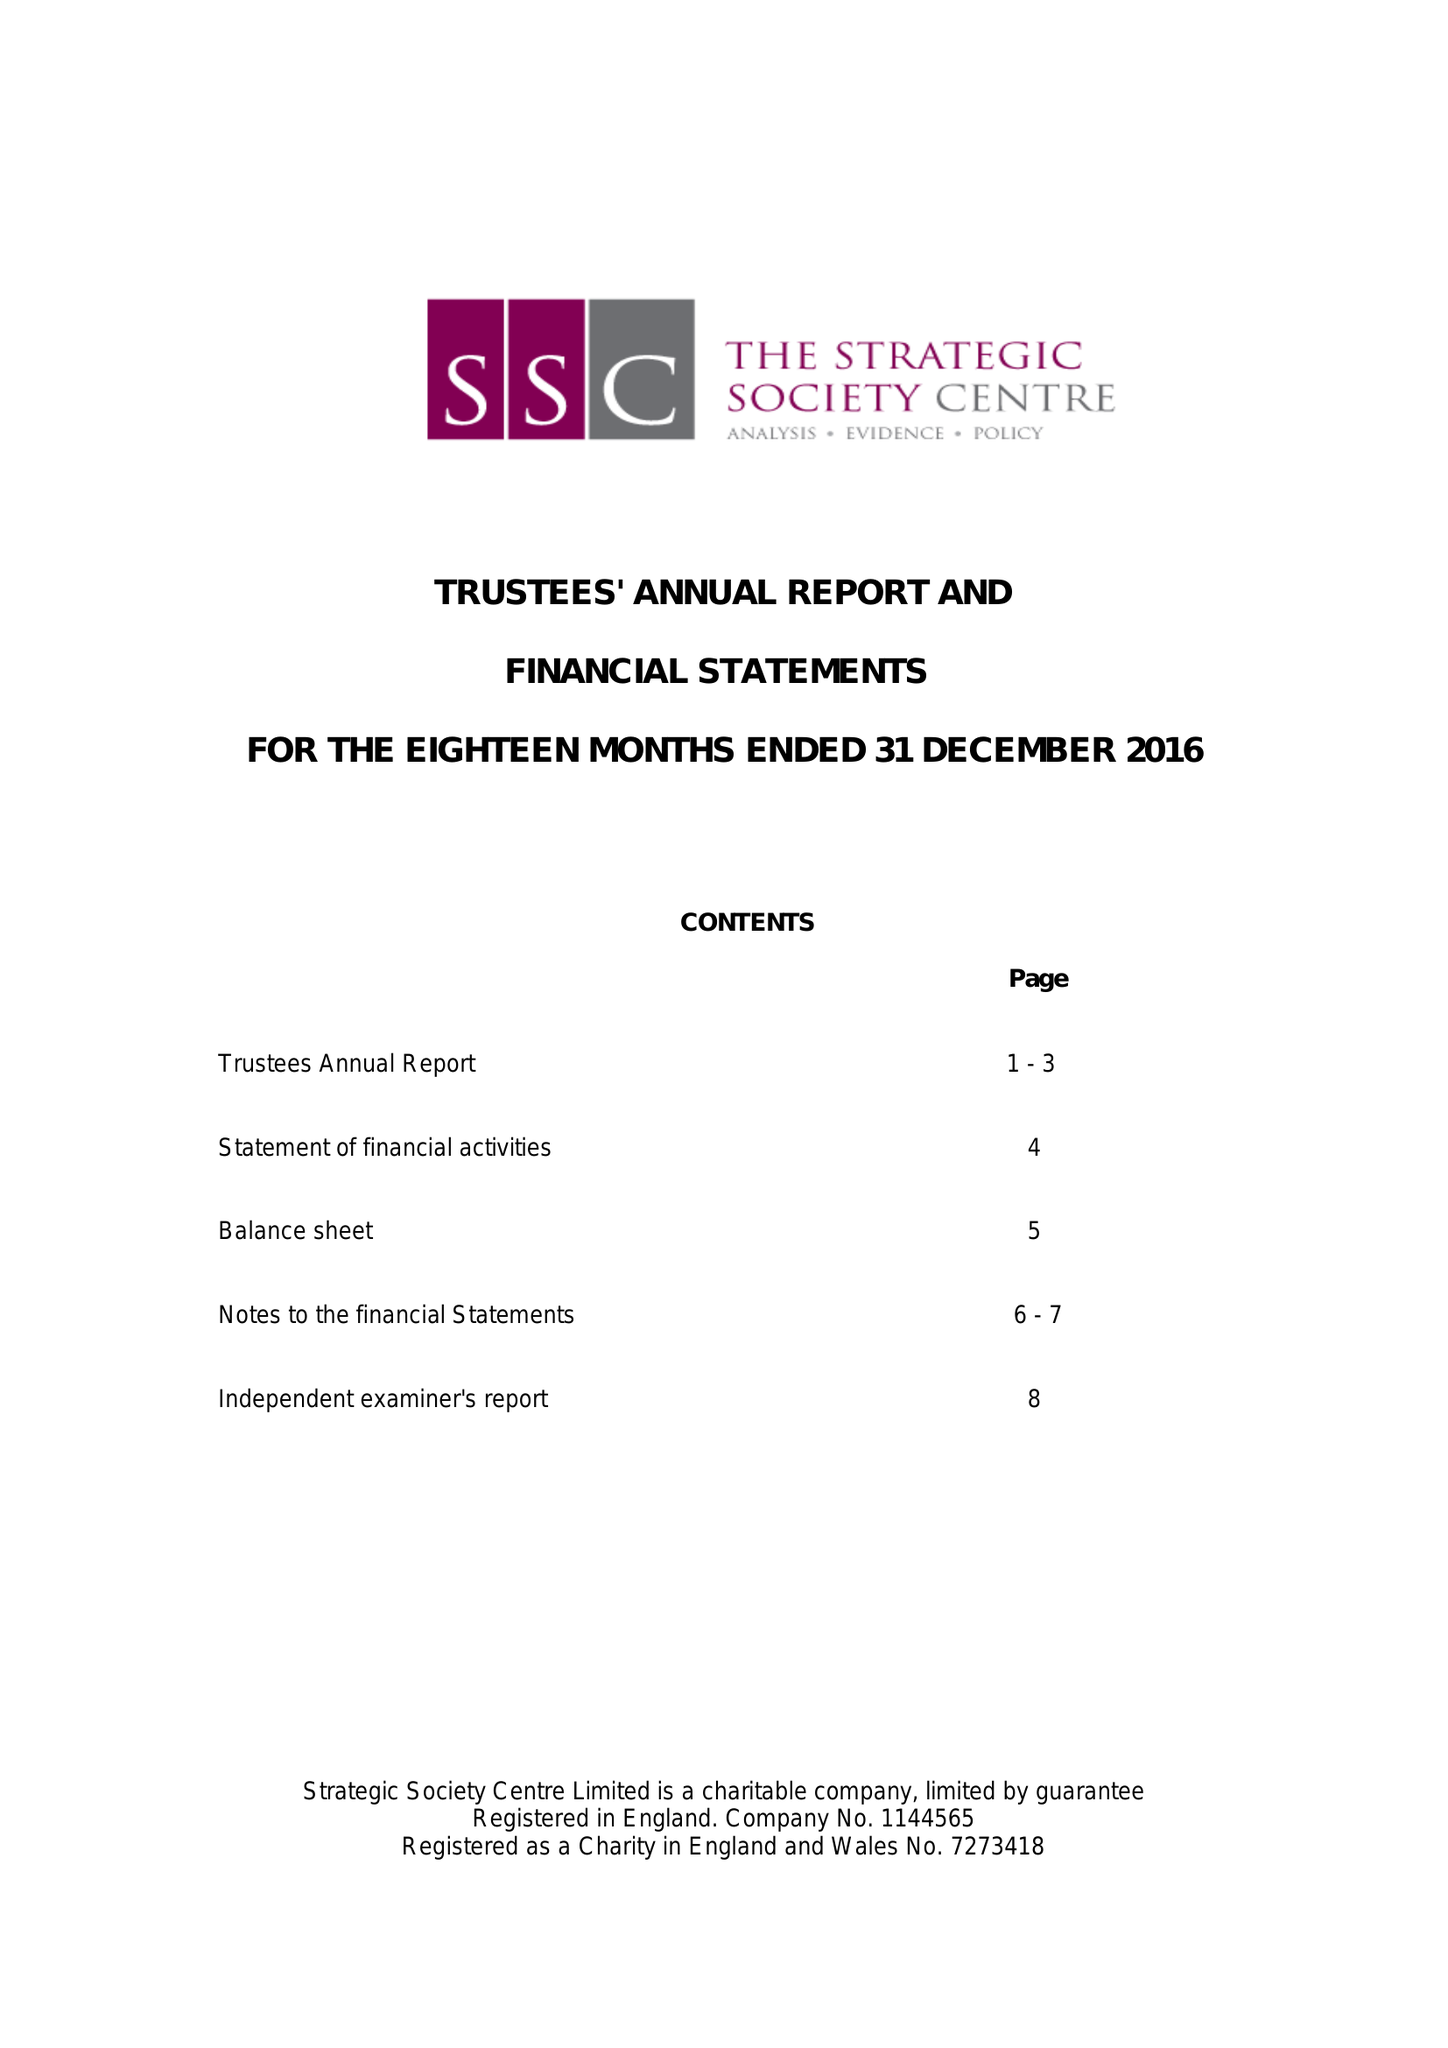What is the value for the charity_number?
Answer the question using a single word or phrase. 1144565 